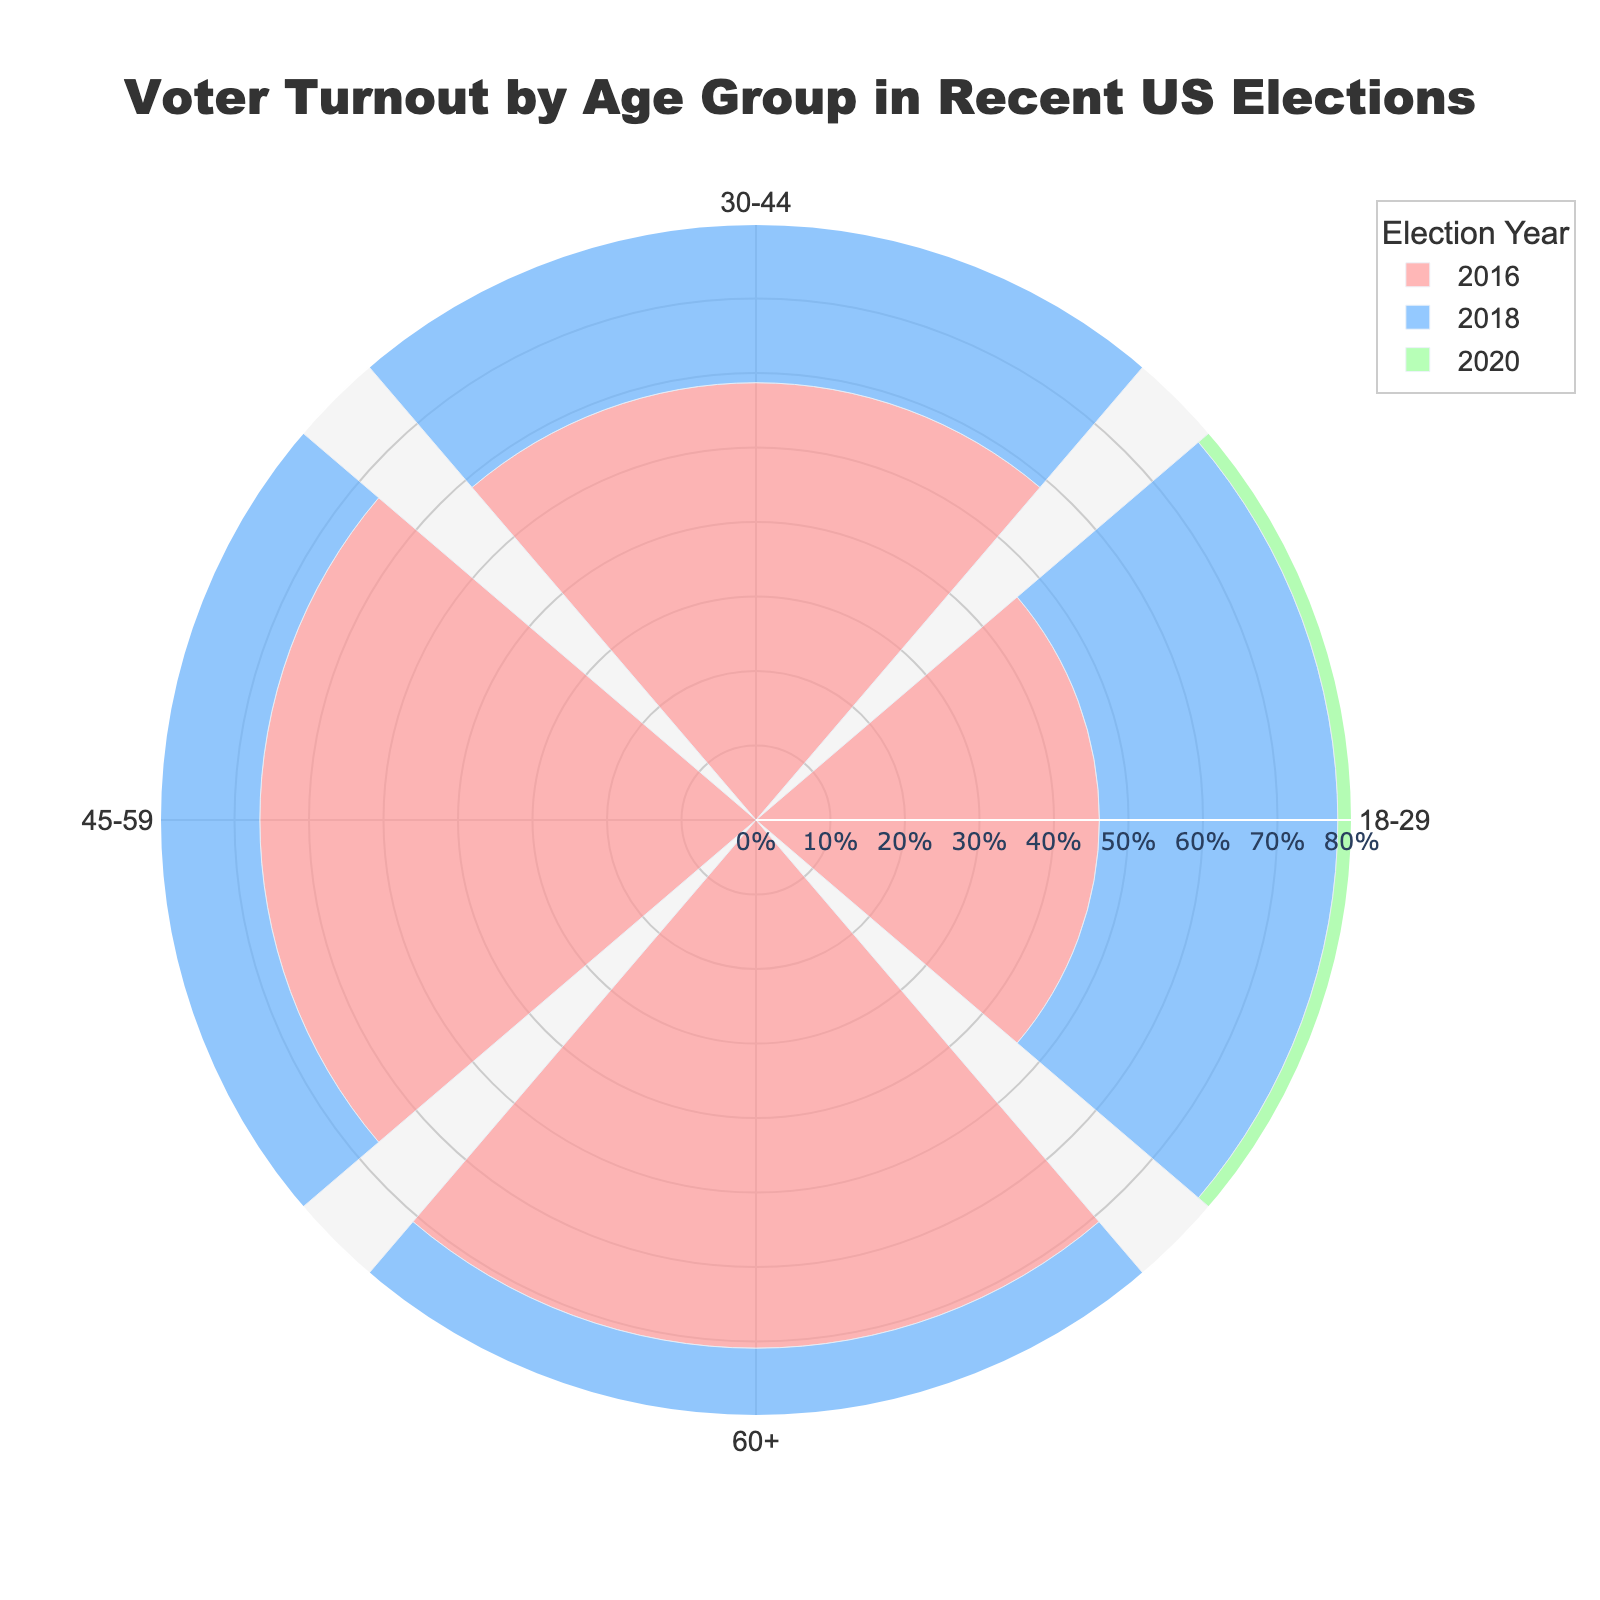what's the title of the figure? The title is located at the top center of the figure and reads "Voter Turnout by Age Group in Recent US Elections".
Answer: Voter Turnout by Age Group in Recent US Elections Which age group had the highest voter turnout in 2020? Locate the outermost bar for the year 2020, which corresponds to the age group 60+ showing the highest voter turnout.
Answer: 60+ How much did voter turnout increase for the 18-29 age group from 2018 to 2020? In 2018, voter turnout for the 18-29 age group was 32.0%, and it rose to 51.4% in 2020. The increase is calculated as 51.4% - 32.0%.
Answer: 19.4% What percentage of voter turnout did the 45-59 age group have in 2016? Find the bar corresponding to the 45-59 age group for the year 2016, which shows a turnout of 66.6%.
Answer: 66.6% Which year had the lowest voter turnout for the 30-44 age group? Identify the shortest bar for the 30-44 age group, which corresponds to the year 2018 with a value of 48.2%.
Answer: 2018 How does the voter turnout for the 60+ age group in 2020 compare to 2016? The voter turnout for the 60+ age group was 70.9% in 2016 and 74.5% in 2020. Comparing these values, 74.5% is higher than 70.9%.
Answer: 74.5% is higher Which age group saw the largest increase in voter turnout from 2018 to 2020? Calculate the increases for each age group between 2018 and 2020: 18-29 increased by 19.4%, 30-44 increased by 14.4%, 45-59 increased by 9.8%, and 60+ increased by 8.4%. The 18-29 age group had the largest increase.
Answer: 18-29 What is the average voter turnout percentage for the 30-44 age group across all three years? Add the voter turnout percentages for 30-44 across 2016 (58.7%), 2018 (48.2%), and 2020 (62.6%), then divide by 3: (58.7 + 48.2 + 62.6) / 3 = 169.5 / 3.
Answer: 56.5% How does the pattern of voter turnout vary across different age groups? Generally, voter turnout increases with age. The youngest group (18-29) consistently has the lowest turnout, whereas the oldest group (60+) has the highest turnout across all three elections.
Answer: Increases with age 